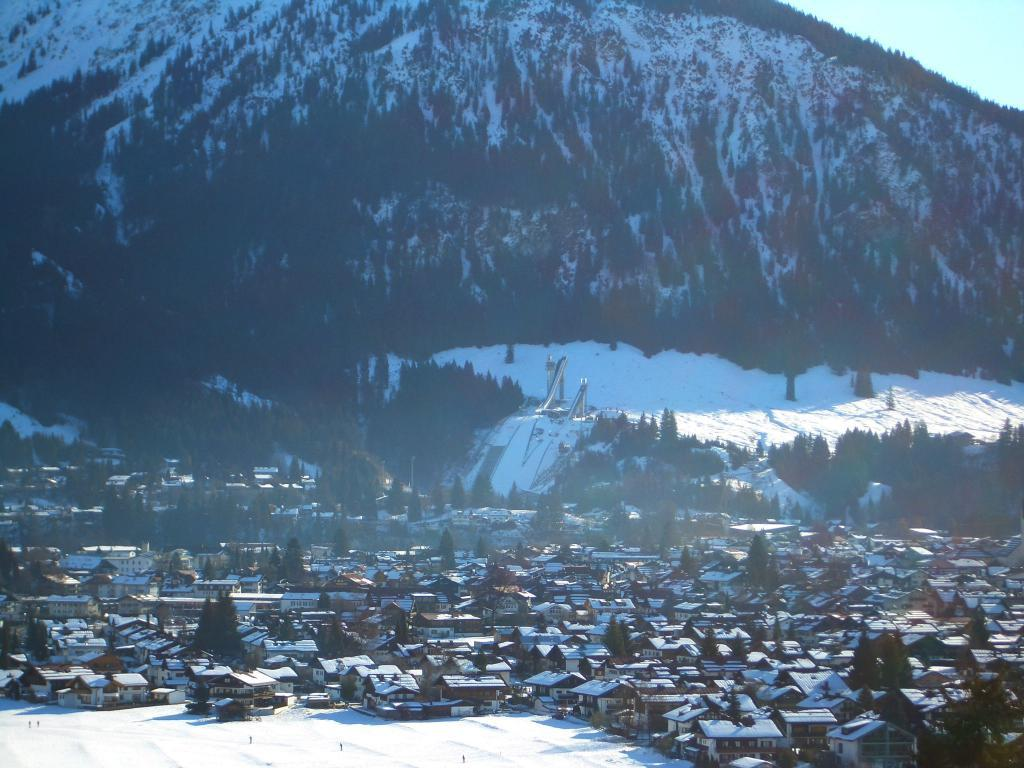What is located at the bottom of the image? There are houses and trees at the bottom of the image, along with snow. What can be seen in the background of the image? There are trees and objects in the background of the image, along with snow. What is at the top of the image? There is a hill and sky at the top of the image. Can you see any cactus plants in the image? There are no cactus plants present in the image; it features snow and trees. What type of cracker is being used to prop up the elbow in the image? There is no cracker or elbow present in the image. 